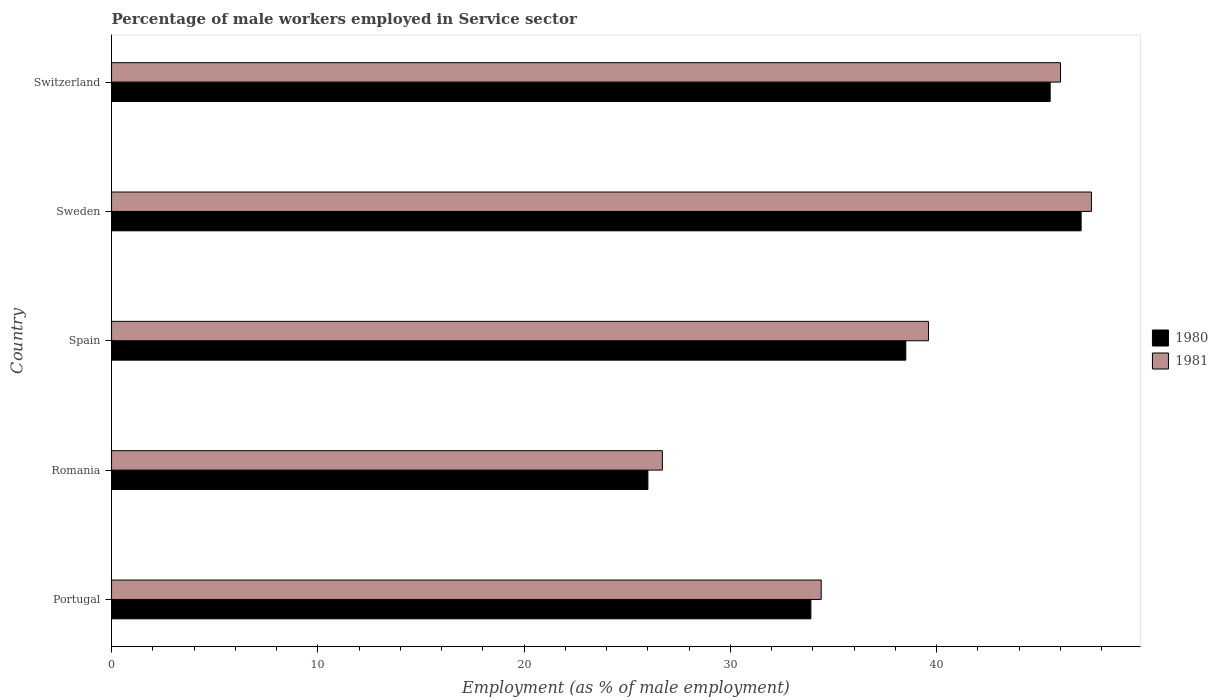How many groups of bars are there?
Give a very brief answer. 5. Are the number of bars per tick equal to the number of legend labels?
Offer a very short reply. Yes. How many bars are there on the 5th tick from the top?
Provide a succinct answer. 2. What is the label of the 3rd group of bars from the top?
Keep it short and to the point. Spain. In how many cases, is the number of bars for a given country not equal to the number of legend labels?
Keep it short and to the point. 0. What is the percentage of male workers employed in Service sector in 1981 in Portugal?
Your answer should be very brief. 34.4. Across all countries, what is the minimum percentage of male workers employed in Service sector in 1981?
Make the answer very short. 26.7. In which country was the percentage of male workers employed in Service sector in 1981 maximum?
Give a very brief answer. Sweden. In which country was the percentage of male workers employed in Service sector in 1980 minimum?
Give a very brief answer. Romania. What is the total percentage of male workers employed in Service sector in 1980 in the graph?
Offer a terse response. 190.9. What is the difference between the percentage of male workers employed in Service sector in 1981 in Portugal and that in Sweden?
Your answer should be very brief. -13.1. What is the difference between the percentage of male workers employed in Service sector in 1981 in Portugal and the percentage of male workers employed in Service sector in 1980 in Romania?
Make the answer very short. 8.4. What is the average percentage of male workers employed in Service sector in 1981 per country?
Offer a terse response. 38.84. What is the ratio of the percentage of male workers employed in Service sector in 1980 in Portugal to that in Switzerland?
Provide a succinct answer. 0.75. What is the difference between the highest and the second highest percentage of male workers employed in Service sector in 1981?
Provide a short and direct response. 1.5. What is the difference between the highest and the lowest percentage of male workers employed in Service sector in 1981?
Keep it short and to the point. 20.8. Is the sum of the percentage of male workers employed in Service sector in 1980 in Spain and Switzerland greater than the maximum percentage of male workers employed in Service sector in 1981 across all countries?
Your answer should be very brief. Yes. What does the 2nd bar from the top in Spain represents?
Your answer should be very brief. 1980. What does the 2nd bar from the bottom in Romania represents?
Ensure brevity in your answer.  1981. What is the title of the graph?
Keep it short and to the point. Percentage of male workers employed in Service sector. What is the label or title of the X-axis?
Provide a succinct answer. Employment (as % of male employment). What is the label or title of the Y-axis?
Your response must be concise. Country. What is the Employment (as % of male employment) in 1980 in Portugal?
Your response must be concise. 33.9. What is the Employment (as % of male employment) of 1981 in Portugal?
Make the answer very short. 34.4. What is the Employment (as % of male employment) of 1980 in Romania?
Provide a succinct answer. 26. What is the Employment (as % of male employment) of 1981 in Romania?
Provide a short and direct response. 26.7. What is the Employment (as % of male employment) in 1980 in Spain?
Offer a terse response. 38.5. What is the Employment (as % of male employment) of 1981 in Spain?
Your answer should be compact. 39.6. What is the Employment (as % of male employment) of 1980 in Sweden?
Give a very brief answer. 47. What is the Employment (as % of male employment) of 1981 in Sweden?
Make the answer very short. 47.5. What is the Employment (as % of male employment) of 1980 in Switzerland?
Give a very brief answer. 45.5. What is the Employment (as % of male employment) in 1981 in Switzerland?
Your response must be concise. 46. Across all countries, what is the maximum Employment (as % of male employment) in 1980?
Ensure brevity in your answer.  47. Across all countries, what is the maximum Employment (as % of male employment) in 1981?
Your answer should be compact. 47.5. Across all countries, what is the minimum Employment (as % of male employment) in 1981?
Make the answer very short. 26.7. What is the total Employment (as % of male employment) of 1980 in the graph?
Your answer should be compact. 190.9. What is the total Employment (as % of male employment) of 1981 in the graph?
Your answer should be very brief. 194.2. What is the difference between the Employment (as % of male employment) in 1981 in Portugal and that in Spain?
Provide a succinct answer. -5.2. What is the difference between the Employment (as % of male employment) in 1981 in Portugal and that in Sweden?
Offer a very short reply. -13.1. What is the difference between the Employment (as % of male employment) of 1981 in Romania and that in Spain?
Make the answer very short. -12.9. What is the difference between the Employment (as % of male employment) of 1981 in Romania and that in Sweden?
Provide a succinct answer. -20.8. What is the difference between the Employment (as % of male employment) in 1980 in Romania and that in Switzerland?
Provide a succinct answer. -19.5. What is the difference between the Employment (as % of male employment) in 1981 in Romania and that in Switzerland?
Offer a terse response. -19.3. What is the difference between the Employment (as % of male employment) of 1981 in Spain and that in Sweden?
Make the answer very short. -7.9. What is the difference between the Employment (as % of male employment) of 1980 in Spain and that in Switzerland?
Ensure brevity in your answer.  -7. What is the difference between the Employment (as % of male employment) of 1981 in Spain and that in Switzerland?
Offer a terse response. -6.4. What is the difference between the Employment (as % of male employment) in 1980 in Sweden and that in Switzerland?
Make the answer very short. 1.5. What is the difference between the Employment (as % of male employment) in 1981 in Sweden and that in Switzerland?
Provide a succinct answer. 1.5. What is the difference between the Employment (as % of male employment) in 1980 in Portugal and the Employment (as % of male employment) in 1981 in Switzerland?
Give a very brief answer. -12.1. What is the difference between the Employment (as % of male employment) of 1980 in Romania and the Employment (as % of male employment) of 1981 in Spain?
Give a very brief answer. -13.6. What is the difference between the Employment (as % of male employment) of 1980 in Romania and the Employment (as % of male employment) of 1981 in Sweden?
Ensure brevity in your answer.  -21.5. What is the difference between the Employment (as % of male employment) of 1980 in Romania and the Employment (as % of male employment) of 1981 in Switzerland?
Offer a terse response. -20. What is the difference between the Employment (as % of male employment) of 1980 in Spain and the Employment (as % of male employment) of 1981 in Switzerland?
Your response must be concise. -7.5. What is the average Employment (as % of male employment) of 1980 per country?
Provide a short and direct response. 38.18. What is the average Employment (as % of male employment) of 1981 per country?
Keep it short and to the point. 38.84. What is the difference between the Employment (as % of male employment) in 1980 and Employment (as % of male employment) in 1981 in Portugal?
Make the answer very short. -0.5. What is the difference between the Employment (as % of male employment) of 1980 and Employment (as % of male employment) of 1981 in Romania?
Your answer should be very brief. -0.7. What is the difference between the Employment (as % of male employment) in 1980 and Employment (as % of male employment) in 1981 in Sweden?
Offer a terse response. -0.5. What is the ratio of the Employment (as % of male employment) of 1980 in Portugal to that in Romania?
Your answer should be compact. 1.3. What is the ratio of the Employment (as % of male employment) in 1981 in Portugal to that in Romania?
Keep it short and to the point. 1.29. What is the ratio of the Employment (as % of male employment) in 1980 in Portugal to that in Spain?
Ensure brevity in your answer.  0.88. What is the ratio of the Employment (as % of male employment) in 1981 in Portugal to that in Spain?
Your response must be concise. 0.87. What is the ratio of the Employment (as % of male employment) in 1980 in Portugal to that in Sweden?
Give a very brief answer. 0.72. What is the ratio of the Employment (as % of male employment) of 1981 in Portugal to that in Sweden?
Your response must be concise. 0.72. What is the ratio of the Employment (as % of male employment) of 1980 in Portugal to that in Switzerland?
Your answer should be compact. 0.75. What is the ratio of the Employment (as % of male employment) of 1981 in Portugal to that in Switzerland?
Provide a short and direct response. 0.75. What is the ratio of the Employment (as % of male employment) of 1980 in Romania to that in Spain?
Your response must be concise. 0.68. What is the ratio of the Employment (as % of male employment) of 1981 in Romania to that in Spain?
Provide a short and direct response. 0.67. What is the ratio of the Employment (as % of male employment) in 1980 in Romania to that in Sweden?
Offer a terse response. 0.55. What is the ratio of the Employment (as % of male employment) of 1981 in Romania to that in Sweden?
Your response must be concise. 0.56. What is the ratio of the Employment (as % of male employment) in 1981 in Romania to that in Switzerland?
Keep it short and to the point. 0.58. What is the ratio of the Employment (as % of male employment) in 1980 in Spain to that in Sweden?
Offer a terse response. 0.82. What is the ratio of the Employment (as % of male employment) of 1981 in Spain to that in Sweden?
Your response must be concise. 0.83. What is the ratio of the Employment (as % of male employment) in 1980 in Spain to that in Switzerland?
Give a very brief answer. 0.85. What is the ratio of the Employment (as % of male employment) of 1981 in Spain to that in Switzerland?
Your response must be concise. 0.86. What is the ratio of the Employment (as % of male employment) in 1980 in Sweden to that in Switzerland?
Your answer should be compact. 1.03. What is the ratio of the Employment (as % of male employment) of 1981 in Sweden to that in Switzerland?
Provide a succinct answer. 1.03. What is the difference between the highest and the second highest Employment (as % of male employment) of 1980?
Make the answer very short. 1.5. What is the difference between the highest and the second highest Employment (as % of male employment) of 1981?
Offer a terse response. 1.5. What is the difference between the highest and the lowest Employment (as % of male employment) of 1981?
Provide a succinct answer. 20.8. 